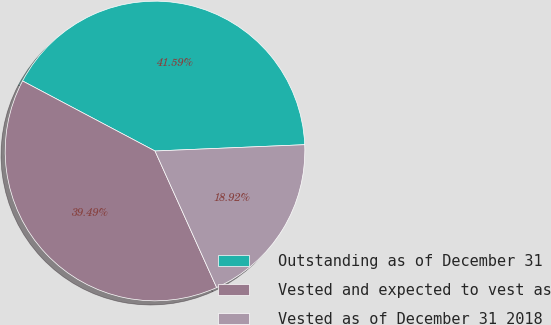Convert chart. <chart><loc_0><loc_0><loc_500><loc_500><pie_chart><fcel>Outstanding as of December 31<fcel>Vested and expected to vest as<fcel>Vested as of December 31 2018<nl><fcel>41.59%<fcel>39.49%<fcel>18.92%<nl></chart> 